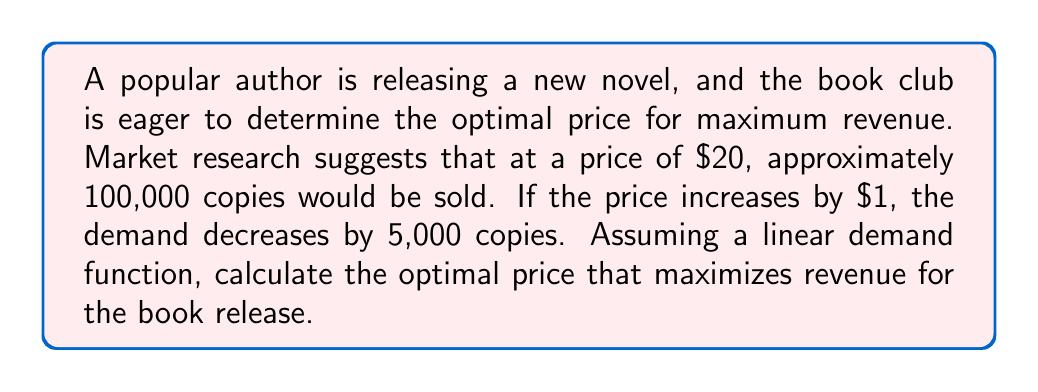Help me with this question. To solve this problem, we'll use the concept of demand elasticity and revenue maximization. Let's approach this step-by-step:

1) First, let's define our variables:
   $p$ = price per book
   $q$ = quantity of books sold
   $R$ = revenue

2) We're given that at $p = 20$, $q = 100,000$, and for every $1 increase in price, quantity decreases by 5,000.

3) We can use this information to form a linear demand function:
   $q = 200,000 - 5,000p$

4) Revenue is price times quantity:
   $R = pq = p(200,000 - 5,000p) = 200,000p - 5,000p^2$

5) To find the maximum revenue, we need to find where the derivative of R with respect to p is zero:
   $$\frac{dR}{dp} = 200,000 - 10,000p$$

6) Set this equal to zero and solve for p:
   $200,000 - 10,000p = 0$
   $200,000 = 10,000p$
   $p = 20$

7) To confirm this is a maximum (not a minimum), we can check the second derivative:
   $$\frac{d^2R}{dp^2} = -10,000$$
   This is negative, confirming we've found a maximum.

8) At $p = 20$, the quantity sold would be:
   $q = 200,000 - 5,000(20) = 100,000$

9) The maximum revenue is therefore:
   $R = 20 * 100,000 = 2,000,000$
Answer: The optimal price that maximizes revenue for the book release is $20, resulting in 100,000 copies sold and a maximum revenue of $2,000,000. 